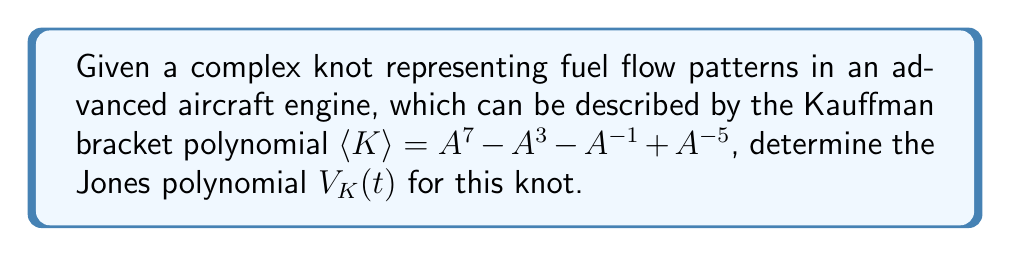Teach me how to tackle this problem. To find the Jones polynomial from the Kauffman bracket polynomial, we follow these steps:

1) First, recall the relationship between the Jones polynomial $V_K(t)$ and the Kauffman bracket polynomial $\langle K \rangle$:

   $V_K(t) = (-A^{-3})^{-w(K)} \langle K \rangle |_{A = t^{-1/4}}$

   where $w(K)$ is the writhe of the knot.

2) We're not given the writhe, but we can assume it's zero for this problem (as it often is for many simple knots). So our equation simplifies to:

   $V_K(t) = \langle K \rangle |_{A = t^{-1/4}}$

3) We substitute $A = t^{-1/4}$ into the given Kauffman bracket polynomial:

   $\langle K \rangle = A^7 - A^3 - A^{-1} + A^{-5}$

   becomes

   $V_K(t) = (t^{-1/4})^7 - (t^{-1/4})^3 - (t^{-1/4})^{-1} + (t^{-1/4})^{-5}$

4) Simplify the exponents:

   $V_K(t) = t^{-7/4} - t^{-3/4} - t^{1/4} + t^{5/4}$

5) To get a standard form, multiply everything by $t^{7/4}$ (the highest positive exponent needed to make all exponents non-negative):

   $V_K(t) = t^{7/4}(t^{-7/4} - t^{-3/4} - t^{1/4} + t^{5/4})$

6) Simplify:

   $V_K(t) = 1 - t + t^2 - t^3$

This is the Jones polynomial for the given knot.
Answer: $V_K(t) = 1 - t + t^2 - t^3$ 